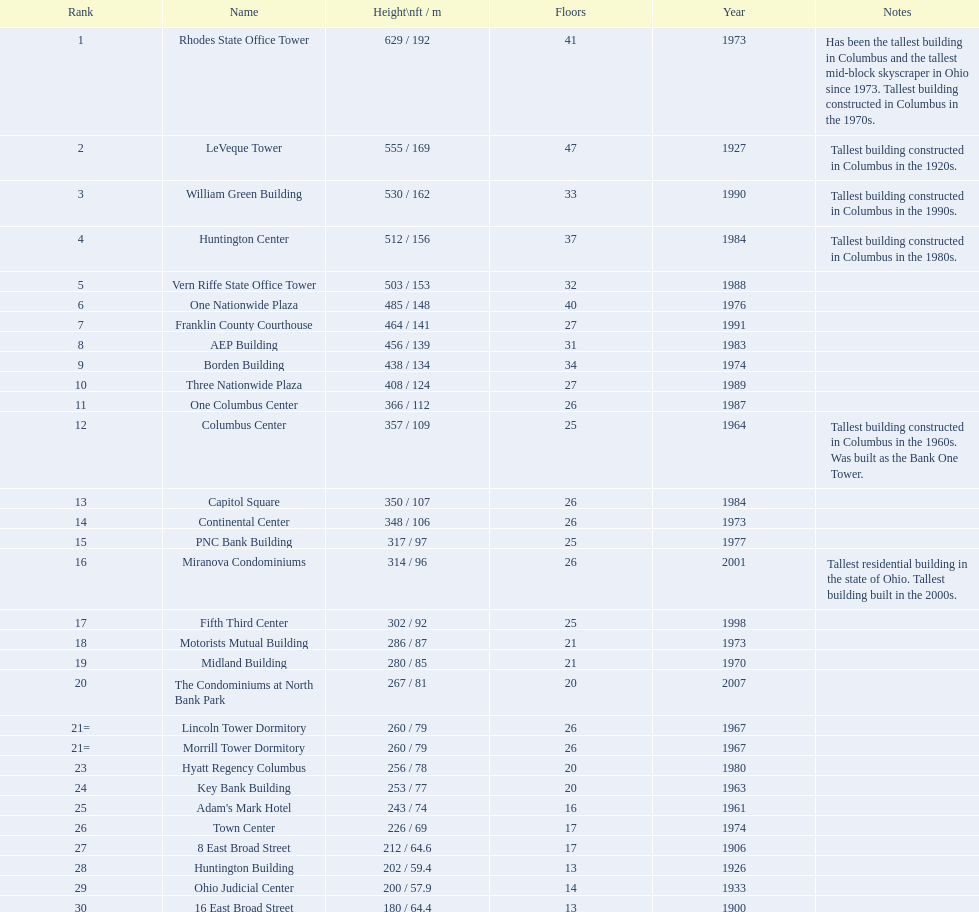Can you give me this table as a dict? {'header': ['Rank', 'Name', 'Height\\nft / m', 'Floors', 'Year', 'Notes'], 'rows': [['1', 'Rhodes State Office Tower', '629 / 192', '41', '1973', 'Has been the tallest building in Columbus and the tallest mid-block skyscraper in Ohio since 1973. Tallest building constructed in Columbus in the 1970s.'], ['2', 'LeVeque Tower', '555 / 169', '47', '1927', 'Tallest building constructed in Columbus in the 1920s.'], ['3', 'William Green Building', '530 / 162', '33', '1990', 'Tallest building constructed in Columbus in the 1990s.'], ['4', 'Huntington Center', '512 / 156', '37', '1984', 'Tallest building constructed in Columbus in the 1980s.'], ['5', 'Vern Riffe State Office Tower', '503 / 153', '32', '1988', ''], ['6', 'One Nationwide Plaza', '485 / 148', '40', '1976', ''], ['7', 'Franklin County Courthouse', '464 / 141', '27', '1991', ''], ['8', 'AEP Building', '456 / 139', '31', '1983', ''], ['9', 'Borden Building', '438 / 134', '34', '1974', ''], ['10', 'Three Nationwide Plaza', '408 / 124', '27', '1989', ''], ['11', 'One Columbus Center', '366 / 112', '26', '1987', ''], ['12', 'Columbus Center', '357 / 109', '25', '1964', 'Tallest building constructed in Columbus in the 1960s. Was built as the Bank One Tower.'], ['13', 'Capitol Square', '350 / 107', '26', '1984', ''], ['14', 'Continental Center', '348 / 106', '26', '1973', ''], ['15', 'PNC Bank Building', '317 / 97', '25', '1977', ''], ['16', 'Miranova Condominiums', '314 / 96', '26', '2001', 'Tallest residential building in the state of Ohio. Tallest building built in the 2000s.'], ['17', 'Fifth Third Center', '302 / 92', '25', '1998', ''], ['18', 'Motorists Mutual Building', '286 / 87', '21', '1973', ''], ['19', 'Midland Building', '280 / 85', '21', '1970', ''], ['20', 'The Condominiums at North Bank Park', '267 / 81', '20', '2007', ''], ['21=', 'Lincoln Tower Dormitory', '260 / 79', '26', '1967', ''], ['21=', 'Morrill Tower Dormitory', '260 / 79', '26', '1967', ''], ['23', 'Hyatt Regency Columbus', '256 / 78', '20', '1980', ''], ['24', 'Key Bank Building', '253 / 77', '20', '1963', ''], ['25', "Adam's Mark Hotel", '243 / 74', '16', '1961', ''], ['26', 'Town Center', '226 / 69', '17', '1974', ''], ['27', '8 East Broad Street', '212 / 64.6', '17', '1906', ''], ['28', 'Huntington Building', '202 / 59.4', '13', '1926', ''], ['29', 'Ohio Judicial Center', '200 / 57.9', '14', '1933', ''], ['30', '16 East Broad Street', '180 / 64.4', '13', '1900', '']]} Can you identify the tallest structure? Rhodes State Office Tower. 